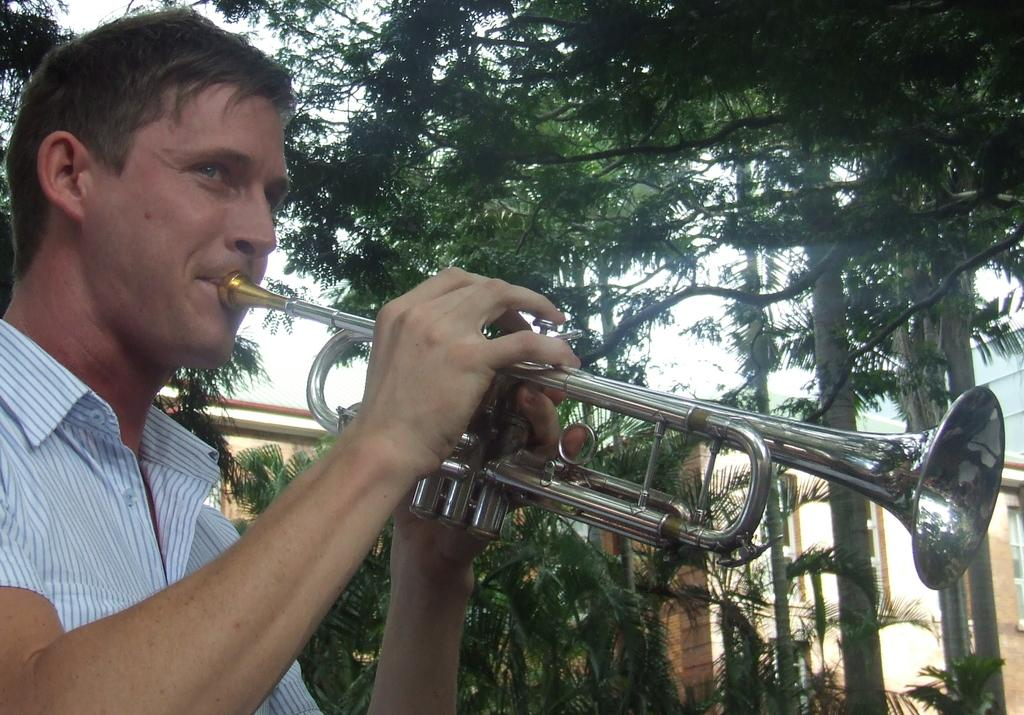What is the main subject of the image? The main subject of the image is a man. What is the man doing in the image? The man is standing and playing a musical instrument. What can be seen in the background of the image? There are plants, trees, a building wall, and the sky visible in the background of the image. What type of noise is the man making while playing the musical instrument in the image? The image does not provide any information about the sound or noise produced by the musical instrument being played by the man. --- 